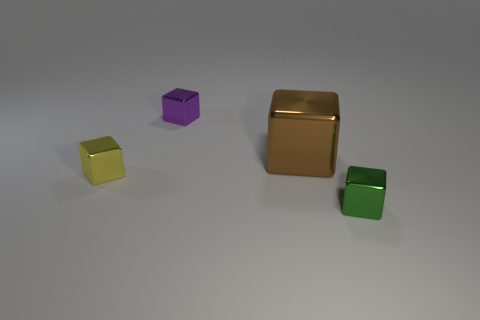Subtract 1 blocks. How many blocks are left? 3 Subtract all gray blocks. Subtract all brown cylinders. How many blocks are left? 4 Add 1 small blue spheres. How many objects exist? 5 Subtract 0 blue blocks. How many objects are left? 4 Subtract all large brown shiny objects. Subtract all tiny green metallic things. How many objects are left? 2 Add 1 green blocks. How many green blocks are left? 2 Add 2 cyan matte cylinders. How many cyan matte cylinders exist? 2 